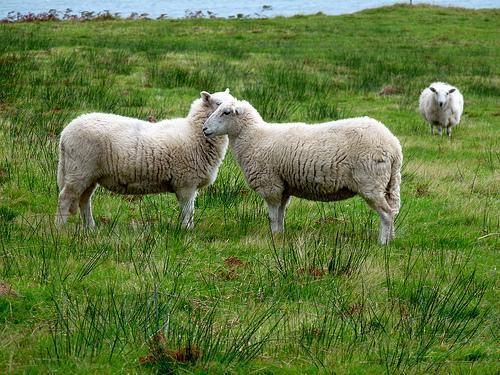How many sheep are shown?
Give a very brief answer. 3. 